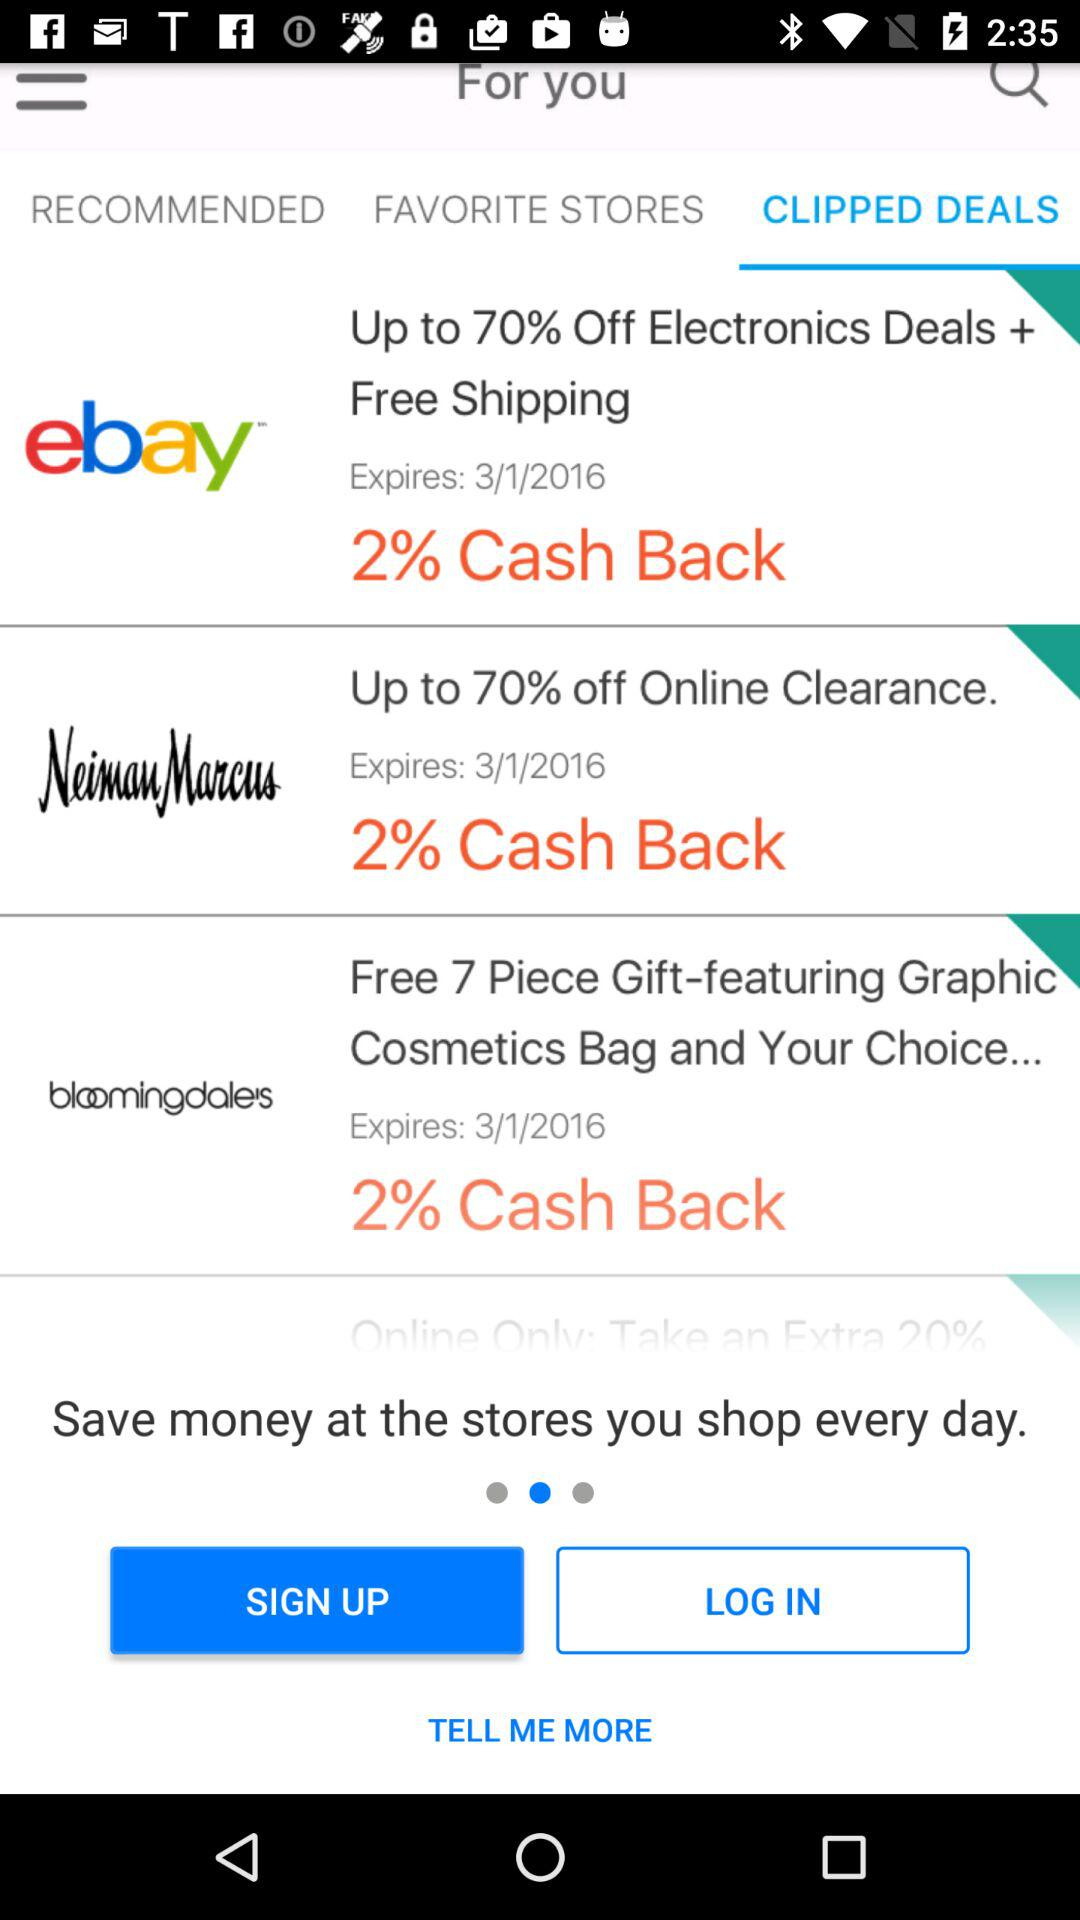How many deals are expiring on 3/1/2016?
Answer the question using a single word or phrase. 3 